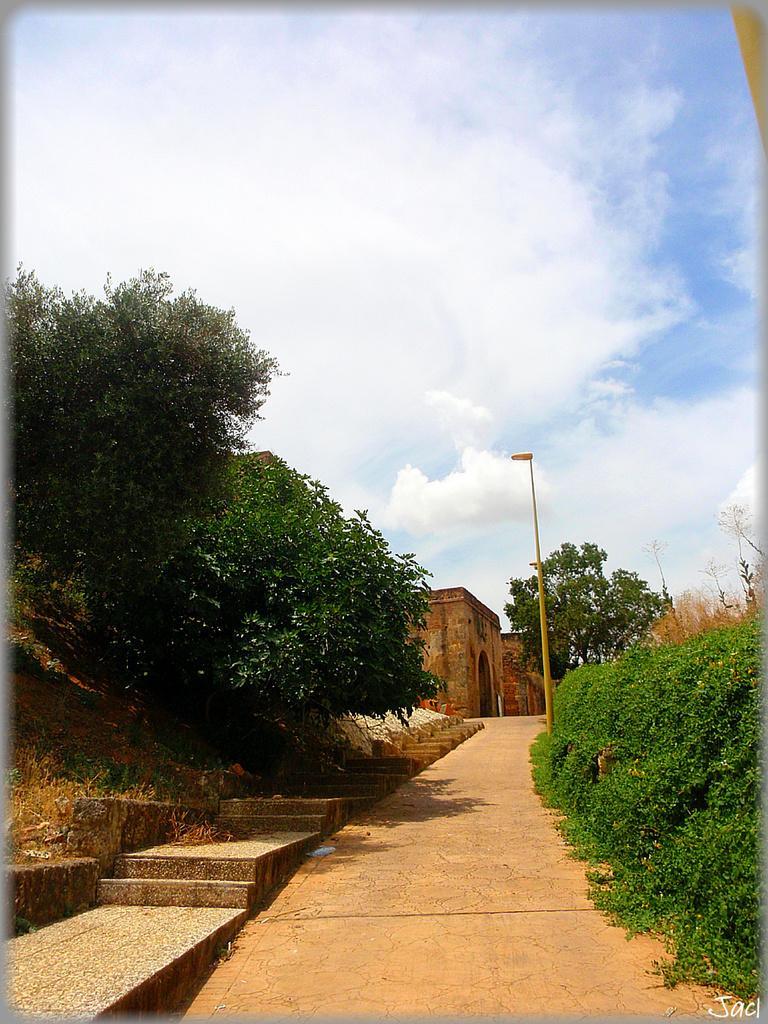Describe this image in one or two sentences. In the picture I can see the road, steps, trees on the either side of the image, we can see pole, stone building and the sky with clouds in the background. 